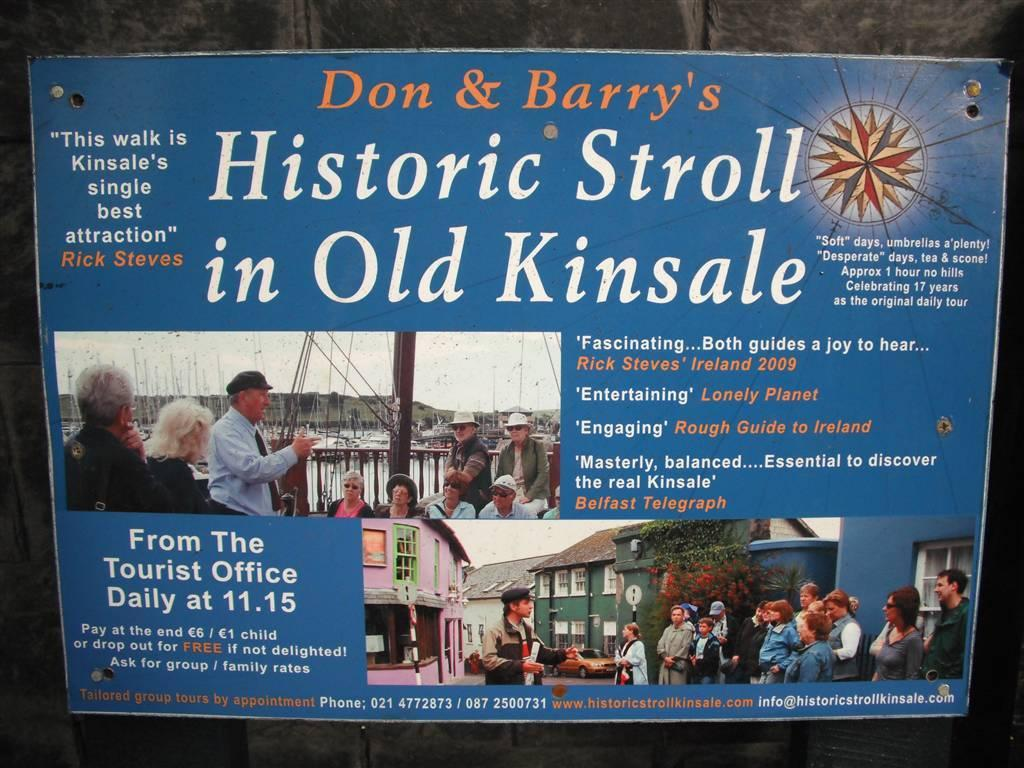What is on the wall in the image? There is a board on the wall in the image. What are people doing on the board? Some people are standing on the board, and some are sitting on the board. What can be seen written on the board? There is writing on the board. What else is on the board besides people? There is a log on the board. What type of metal is being distributed on the wall in the image? There is no metal being distributed on the wall in the image; it features a board with people, writing, and a log. 